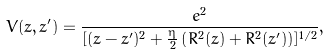Convert formula to latex. <formula><loc_0><loc_0><loc_500><loc_500>V ( z , z ^ { \prime } ) = \frac { e ^ { 2 } } { [ ( z - z ^ { \prime } ) ^ { 2 } + \frac { \eta } { 2 } \left ( R ^ { 2 } ( z ) + R ^ { 2 } ( z ^ { \prime } ) \right ) ] ^ { 1 / 2 } } ,</formula> 